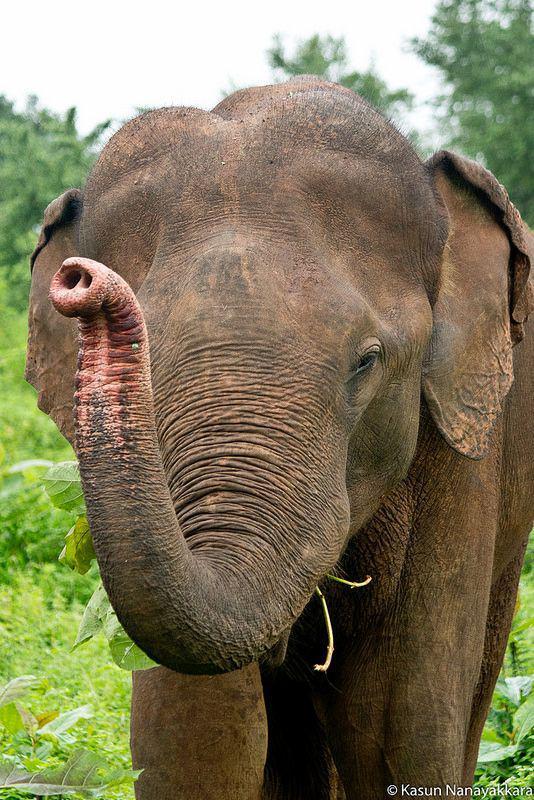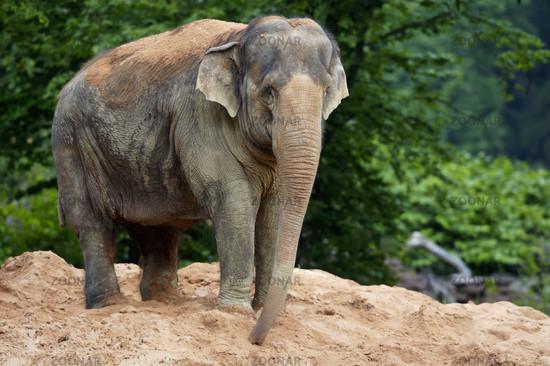The first image is the image on the left, the second image is the image on the right. Examine the images to the left and right. Is the description "One of the images contains more than three elephants." accurate? Answer yes or no. No. 